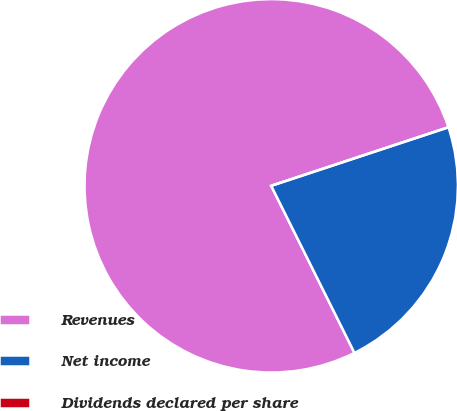Convert chart. <chart><loc_0><loc_0><loc_500><loc_500><pie_chart><fcel>Revenues<fcel>Net income<fcel>Dividends declared per share<nl><fcel>77.28%<fcel>22.72%<fcel>0.0%<nl></chart> 